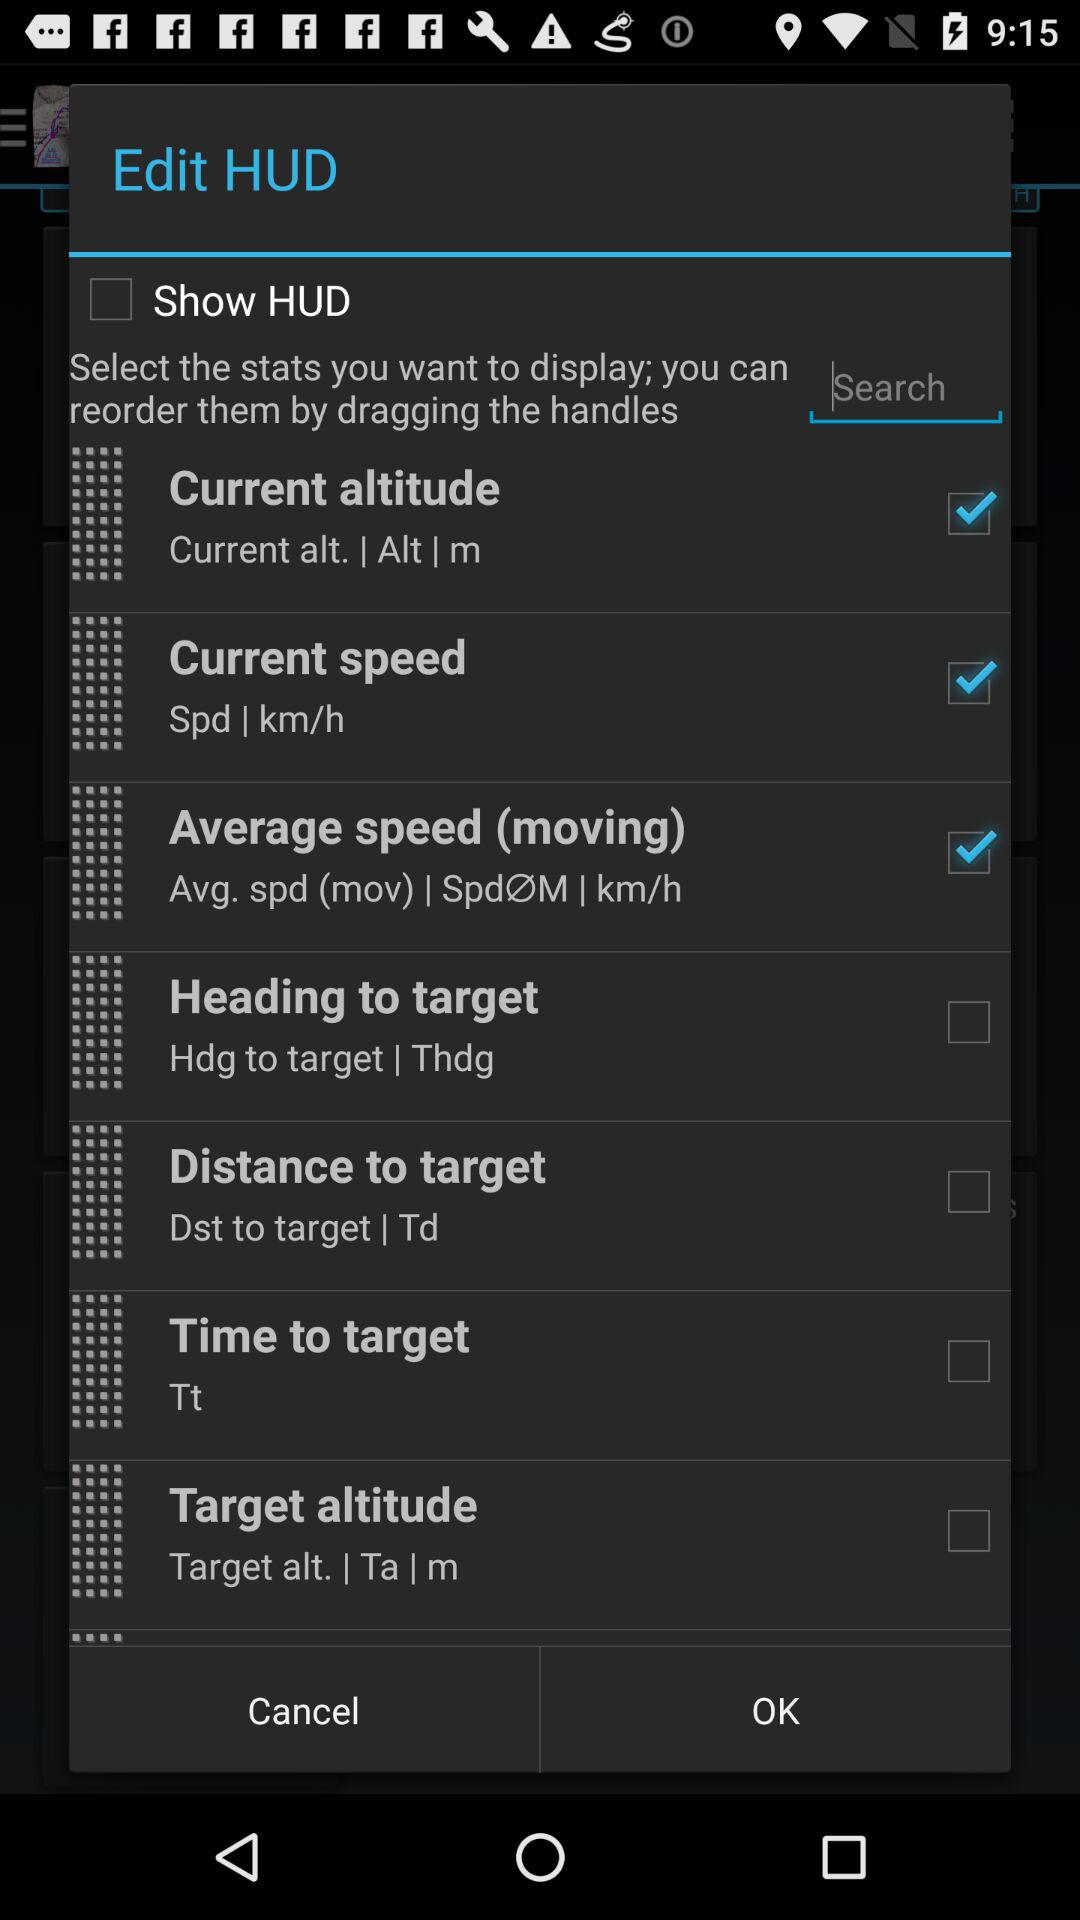What are the selected options? The selected options are "Current altitude", "Current speed" and "Average speed (moving)". 